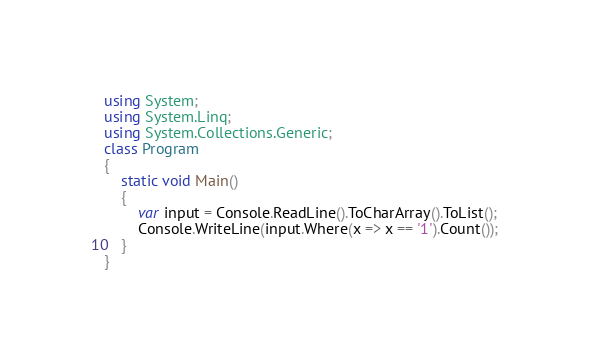<code> <loc_0><loc_0><loc_500><loc_500><_C#_>using System;
using System.Linq;
using System.Collections.Generic;
class Program
{
    static void Main()
    {
        var input = Console.ReadLine().ToCharArray().ToList();
        Console.WriteLine(input.Where(x => x == '1').Count());
    }
}</code> 